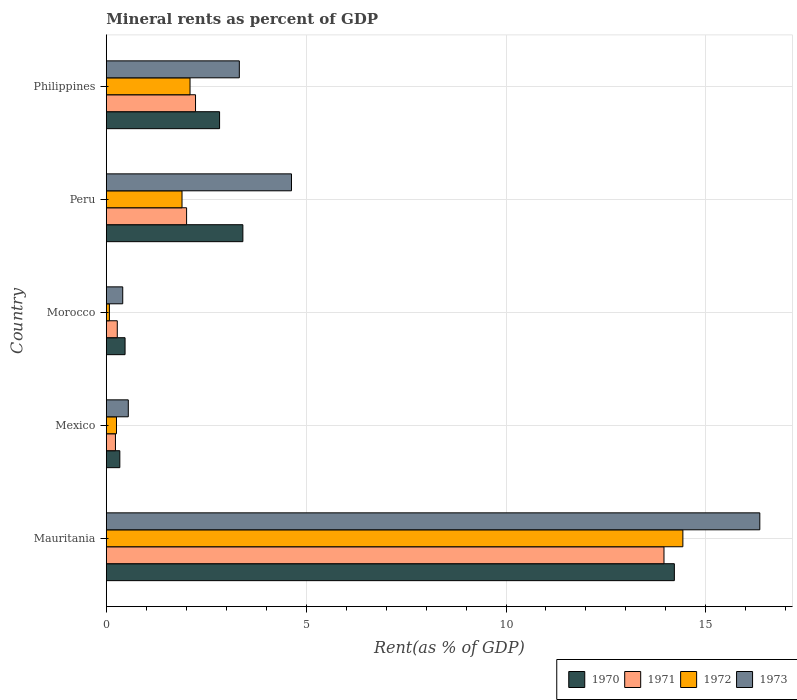How many groups of bars are there?
Ensure brevity in your answer.  5. How many bars are there on the 5th tick from the top?
Offer a terse response. 4. How many bars are there on the 4th tick from the bottom?
Your answer should be compact. 4. What is the label of the 4th group of bars from the top?
Give a very brief answer. Mexico. In how many cases, is the number of bars for a given country not equal to the number of legend labels?
Provide a succinct answer. 0. What is the mineral rent in 1970 in Morocco?
Offer a very short reply. 0.47. Across all countries, what is the maximum mineral rent in 1971?
Make the answer very short. 13.95. Across all countries, what is the minimum mineral rent in 1973?
Offer a terse response. 0.41. In which country was the mineral rent in 1973 maximum?
Ensure brevity in your answer.  Mauritania. What is the total mineral rent in 1971 in the graph?
Keep it short and to the point. 18.69. What is the difference between the mineral rent in 1971 in Mauritania and that in Philippines?
Your answer should be very brief. 11.72. What is the difference between the mineral rent in 1970 in Morocco and the mineral rent in 1973 in Mauritania?
Ensure brevity in your answer.  -15.88. What is the average mineral rent in 1970 per country?
Your response must be concise. 4.25. What is the difference between the mineral rent in 1970 and mineral rent in 1973 in Morocco?
Ensure brevity in your answer.  0.06. What is the ratio of the mineral rent in 1970 in Morocco to that in Philippines?
Your response must be concise. 0.17. What is the difference between the highest and the second highest mineral rent in 1971?
Your response must be concise. 11.72. What is the difference between the highest and the lowest mineral rent in 1973?
Provide a succinct answer. 15.94. Is the sum of the mineral rent in 1970 in Morocco and Peru greater than the maximum mineral rent in 1972 across all countries?
Ensure brevity in your answer.  No. Is it the case that in every country, the sum of the mineral rent in 1972 and mineral rent in 1971 is greater than the sum of mineral rent in 1973 and mineral rent in 1970?
Offer a terse response. No. What does the 3rd bar from the top in Morocco represents?
Your response must be concise. 1971. Is it the case that in every country, the sum of the mineral rent in 1972 and mineral rent in 1970 is greater than the mineral rent in 1973?
Offer a very short reply. Yes. Are all the bars in the graph horizontal?
Offer a terse response. Yes. How many countries are there in the graph?
Offer a very short reply. 5. Are the values on the major ticks of X-axis written in scientific E-notation?
Your answer should be compact. No. How many legend labels are there?
Your answer should be compact. 4. What is the title of the graph?
Your answer should be compact. Mineral rents as percent of GDP. What is the label or title of the X-axis?
Offer a very short reply. Rent(as % of GDP). What is the label or title of the Y-axis?
Your response must be concise. Country. What is the Rent(as % of GDP) in 1970 in Mauritania?
Offer a very short reply. 14.21. What is the Rent(as % of GDP) of 1971 in Mauritania?
Offer a terse response. 13.95. What is the Rent(as % of GDP) in 1972 in Mauritania?
Give a very brief answer. 14.43. What is the Rent(as % of GDP) of 1973 in Mauritania?
Give a very brief answer. 16.35. What is the Rent(as % of GDP) of 1970 in Mexico?
Make the answer very short. 0.34. What is the Rent(as % of GDP) in 1971 in Mexico?
Make the answer very short. 0.23. What is the Rent(as % of GDP) in 1972 in Mexico?
Provide a short and direct response. 0.25. What is the Rent(as % of GDP) in 1973 in Mexico?
Ensure brevity in your answer.  0.55. What is the Rent(as % of GDP) in 1970 in Morocco?
Make the answer very short. 0.47. What is the Rent(as % of GDP) in 1971 in Morocco?
Make the answer very short. 0.27. What is the Rent(as % of GDP) of 1972 in Morocco?
Provide a short and direct response. 0.08. What is the Rent(as % of GDP) of 1973 in Morocco?
Your answer should be very brief. 0.41. What is the Rent(as % of GDP) in 1970 in Peru?
Your response must be concise. 3.42. What is the Rent(as % of GDP) of 1971 in Peru?
Your response must be concise. 2.01. What is the Rent(as % of GDP) in 1972 in Peru?
Provide a succinct answer. 1.89. What is the Rent(as % of GDP) of 1973 in Peru?
Your answer should be very brief. 4.63. What is the Rent(as % of GDP) of 1970 in Philippines?
Offer a very short reply. 2.83. What is the Rent(as % of GDP) in 1971 in Philippines?
Make the answer very short. 2.23. What is the Rent(as % of GDP) in 1972 in Philippines?
Keep it short and to the point. 2.09. What is the Rent(as % of GDP) of 1973 in Philippines?
Ensure brevity in your answer.  3.33. Across all countries, what is the maximum Rent(as % of GDP) in 1970?
Ensure brevity in your answer.  14.21. Across all countries, what is the maximum Rent(as % of GDP) of 1971?
Provide a succinct answer. 13.95. Across all countries, what is the maximum Rent(as % of GDP) of 1972?
Your answer should be very brief. 14.43. Across all countries, what is the maximum Rent(as % of GDP) in 1973?
Your response must be concise. 16.35. Across all countries, what is the minimum Rent(as % of GDP) of 1970?
Your answer should be compact. 0.34. Across all countries, what is the minimum Rent(as % of GDP) in 1971?
Give a very brief answer. 0.23. Across all countries, what is the minimum Rent(as % of GDP) of 1972?
Ensure brevity in your answer.  0.08. Across all countries, what is the minimum Rent(as % of GDP) of 1973?
Your response must be concise. 0.41. What is the total Rent(as % of GDP) of 1970 in the graph?
Give a very brief answer. 21.27. What is the total Rent(as % of GDP) of 1971 in the graph?
Provide a short and direct response. 18.69. What is the total Rent(as % of GDP) of 1972 in the graph?
Your answer should be compact. 18.74. What is the total Rent(as % of GDP) in 1973 in the graph?
Keep it short and to the point. 25.27. What is the difference between the Rent(as % of GDP) in 1970 in Mauritania and that in Mexico?
Offer a terse response. 13.88. What is the difference between the Rent(as % of GDP) of 1971 in Mauritania and that in Mexico?
Offer a very short reply. 13.72. What is the difference between the Rent(as % of GDP) in 1972 in Mauritania and that in Mexico?
Offer a terse response. 14.17. What is the difference between the Rent(as % of GDP) of 1973 in Mauritania and that in Mexico?
Provide a short and direct response. 15.8. What is the difference between the Rent(as % of GDP) in 1970 in Mauritania and that in Morocco?
Keep it short and to the point. 13.74. What is the difference between the Rent(as % of GDP) in 1971 in Mauritania and that in Morocco?
Provide a succinct answer. 13.68. What is the difference between the Rent(as % of GDP) of 1972 in Mauritania and that in Morocco?
Keep it short and to the point. 14.35. What is the difference between the Rent(as % of GDP) in 1973 in Mauritania and that in Morocco?
Offer a very short reply. 15.94. What is the difference between the Rent(as % of GDP) in 1970 in Mauritania and that in Peru?
Your response must be concise. 10.8. What is the difference between the Rent(as % of GDP) in 1971 in Mauritania and that in Peru?
Offer a terse response. 11.94. What is the difference between the Rent(as % of GDP) of 1972 in Mauritania and that in Peru?
Keep it short and to the point. 12.53. What is the difference between the Rent(as % of GDP) of 1973 in Mauritania and that in Peru?
Make the answer very short. 11.72. What is the difference between the Rent(as % of GDP) in 1970 in Mauritania and that in Philippines?
Make the answer very short. 11.38. What is the difference between the Rent(as % of GDP) of 1971 in Mauritania and that in Philippines?
Ensure brevity in your answer.  11.72. What is the difference between the Rent(as % of GDP) of 1972 in Mauritania and that in Philippines?
Ensure brevity in your answer.  12.33. What is the difference between the Rent(as % of GDP) in 1973 in Mauritania and that in Philippines?
Your answer should be compact. 13.02. What is the difference between the Rent(as % of GDP) of 1970 in Mexico and that in Morocco?
Your answer should be compact. -0.13. What is the difference between the Rent(as % of GDP) in 1971 in Mexico and that in Morocco?
Offer a very short reply. -0.05. What is the difference between the Rent(as % of GDP) in 1972 in Mexico and that in Morocco?
Offer a terse response. 0.18. What is the difference between the Rent(as % of GDP) of 1973 in Mexico and that in Morocco?
Ensure brevity in your answer.  0.14. What is the difference between the Rent(as % of GDP) of 1970 in Mexico and that in Peru?
Offer a very short reply. -3.08. What is the difference between the Rent(as % of GDP) in 1971 in Mexico and that in Peru?
Ensure brevity in your answer.  -1.78. What is the difference between the Rent(as % of GDP) in 1972 in Mexico and that in Peru?
Your answer should be very brief. -1.64. What is the difference between the Rent(as % of GDP) of 1973 in Mexico and that in Peru?
Your response must be concise. -4.08. What is the difference between the Rent(as % of GDP) of 1970 in Mexico and that in Philippines?
Offer a terse response. -2.5. What is the difference between the Rent(as % of GDP) of 1971 in Mexico and that in Philippines?
Your response must be concise. -2. What is the difference between the Rent(as % of GDP) of 1972 in Mexico and that in Philippines?
Provide a succinct answer. -1.84. What is the difference between the Rent(as % of GDP) of 1973 in Mexico and that in Philippines?
Give a very brief answer. -2.78. What is the difference between the Rent(as % of GDP) in 1970 in Morocco and that in Peru?
Provide a short and direct response. -2.95. What is the difference between the Rent(as % of GDP) in 1971 in Morocco and that in Peru?
Provide a succinct answer. -1.73. What is the difference between the Rent(as % of GDP) of 1972 in Morocco and that in Peru?
Make the answer very short. -1.82. What is the difference between the Rent(as % of GDP) of 1973 in Morocco and that in Peru?
Offer a terse response. -4.22. What is the difference between the Rent(as % of GDP) in 1970 in Morocco and that in Philippines?
Your response must be concise. -2.36. What is the difference between the Rent(as % of GDP) in 1971 in Morocco and that in Philippines?
Make the answer very short. -1.96. What is the difference between the Rent(as % of GDP) of 1972 in Morocco and that in Philippines?
Offer a very short reply. -2.02. What is the difference between the Rent(as % of GDP) in 1973 in Morocco and that in Philippines?
Make the answer very short. -2.92. What is the difference between the Rent(as % of GDP) in 1970 in Peru and that in Philippines?
Make the answer very short. 0.58. What is the difference between the Rent(as % of GDP) in 1971 in Peru and that in Philippines?
Give a very brief answer. -0.22. What is the difference between the Rent(as % of GDP) of 1972 in Peru and that in Philippines?
Provide a succinct answer. -0.2. What is the difference between the Rent(as % of GDP) of 1973 in Peru and that in Philippines?
Give a very brief answer. 1.31. What is the difference between the Rent(as % of GDP) in 1970 in Mauritania and the Rent(as % of GDP) in 1971 in Mexico?
Make the answer very short. 13.98. What is the difference between the Rent(as % of GDP) of 1970 in Mauritania and the Rent(as % of GDP) of 1972 in Mexico?
Make the answer very short. 13.96. What is the difference between the Rent(as % of GDP) in 1970 in Mauritania and the Rent(as % of GDP) in 1973 in Mexico?
Your answer should be very brief. 13.66. What is the difference between the Rent(as % of GDP) of 1971 in Mauritania and the Rent(as % of GDP) of 1972 in Mexico?
Keep it short and to the point. 13.7. What is the difference between the Rent(as % of GDP) in 1971 in Mauritania and the Rent(as % of GDP) in 1973 in Mexico?
Your answer should be very brief. 13.4. What is the difference between the Rent(as % of GDP) of 1972 in Mauritania and the Rent(as % of GDP) of 1973 in Mexico?
Make the answer very short. 13.88. What is the difference between the Rent(as % of GDP) in 1970 in Mauritania and the Rent(as % of GDP) in 1971 in Morocco?
Provide a succinct answer. 13.94. What is the difference between the Rent(as % of GDP) of 1970 in Mauritania and the Rent(as % of GDP) of 1972 in Morocco?
Ensure brevity in your answer.  14.14. What is the difference between the Rent(as % of GDP) of 1970 in Mauritania and the Rent(as % of GDP) of 1973 in Morocco?
Make the answer very short. 13.8. What is the difference between the Rent(as % of GDP) of 1971 in Mauritania and the Rent(as % of GDP) of 1972 in Morocco?
Make the answer very short. 13.88. What is the difference between the Rent(as % of GDP) in 1971 in Mauritania and the Rent(as % of GDP) in 1973 in Morocco?
Give a very brief answer. 13.54. What is the difference between the Rent(as % of GDP) in 1972 in Mauritania and the Rent(as % of GDP) in 1973 in Morocco?
Offer a terse response. 14.02. What is the difference between the Rent(as % of GDP) in 1970 in Mauritania and the Rent(as % of GDP) in 1971 in Peru?
Ensure brevity in your answer.  12.2. What is the difference between the Rent(as % of GDP) in 1970 in Mauritania and the Rent(as % of GDP) in 1972 in Peru?
Keep it short and to the point. 12.32. What is the difference between the Rent(as % of GDP) in 1970 in Mauritania and the Rent(as % of GDP) in 1973 in Peru?
Provide a succinct answer. 9.58. What is the difference between the Rent(as % of GDP) in 1971 in Mauritania and the Rent(as % of GDP) in 1972 in Peru?
Offer a very short reply. 12.06. What is the difference between the Rent(as % of GDP) in 1971 in Mauritania and the Rent(as % of GDP) in 1973 in Peru?
Give a very brief answer. 9.32. What is the difference between the Rent(as % of GDP) in 1972 in Mauritania and the Rent(as % of GDP) in 1973 in Peru?
Provide a succinct answer. 9.79. What is the difference between the Rent(as % of GDP) of 1970 in Mauritania and the Rent(as % of GDP) of 1971 in Philippines?
Provide a short and direct response. 11.98. What is the difference between the Rent(as % of GDP) in 1970 in Mauritania and the Rent(as % of GDP) in 1972 in Philippines?
Provide a short and direct response. 12.12. What is the difference between the Rent(as % of GDP) in 1970 in Mauritania and the Rent(as % of GDP) in 1973 in Philippines?
Ensure brevity in your answer.  10.89. What is the difference between the Rent(as % of GDP) in 1971 in Mauritania and the Rent(as % of GDP) in 1972 in Philippines?
Keep it short and to the point. 11.86. What is the difference between the Rent(as % of GDP) of 1971 in Mauritania and the Rent(as % of GDP) of 1973 in Philippines?
Provide a short and direct response. 10.63. What is the difference between the Rent(as % of GDP) of 1972 in Mauritania and the Rent(as % of GDP) of 1973 in Philippines?
Offer a very short reply. 11.1. What is the difference between the Rent(as % of GDP) of 1970 in Mexico and the Rent(as % of GDP) of 1971 in Morocco?
Provide a succinct answer. 0.06. What is the difference between the Rent(as % of GDP) of 1970 in Mexico and the Rent(as % of GDP) of 1972 in Morocco?
Ensure brevity in your answer.  0.26. What is the difference between the Rent(as % of GDP) in 1970 in Mexico and the Rent(as % of GDP) in 1973 in Morocco?
Your response must be concise. -0.07. What is the difference between the Rent(as % of GDP) in 1971 in Mexico and the Rent(as % of GDP) in 1972 in Morocco?
Offer a terse response. 0.15. What is the difference between the Rent(as % of GDP) of 1971 in Mexico and the Rent(as % of GDP) of 1973 in Morocco?
Keep it short and to the point. -0.18. What is the difference between the Rent(as % of GDP) of 1972 in Mexico and the Rent(as % of GDP) of 1973 in Morocco?
Provide a succinct answer. -0.16. What is the difference between the Rent(as % of GDP) in 1970 in Mexico and the Rent(as % of GDP) in 1971 in Peru?
Offer a very short reply. -1.67. What is the difference between the Rent(as % of GDP) of 1970 in Mexico and the Rent(as % of GDP) of 1972 in Peru?
Offer a terse response. -1.56. What is the difference between the Rent(as % of GDP) of 1970 in Mexico and the Rent(as % of GDP) of 1973 in Peru?
Offer a very short reply. -4.29. What is the difference between the Rent(as % of GDP) of 1971 in Mexico and the Rent(as % of GDP) of 1972 in Peru?
Your answer should be very brief. -1.67. What is the difference between the Rent(as % of GDP) in 1971 in Mexico and the Rent(as % of GDP) in 1973 in Peru?
Offer a very short reply. -4.4. What is the difference between the Rent(as % of GDP) of 1972 in Mexico and the Rent(as % of GDP) of 1973 in Peru?
Ensure brevity in your answer.  -4.38. What is the difference between the Rent(as % of GDP) of 1970 in Mexico and the Rent(as % of GDP) of 1971 in Philippines?
Offer a very short reply. -1.89. What is the difference between the Rent(as % of GDP) of 1970 in Mexico and the Rent(as % of GDP) of 1972 in Philippines?
Keep it short and to the point. -1.76. What is the difference between the Rent(as % of GDP) of 1970 in Mexico and the Rent(as % of GDP) of 1973 in Philippines?
Offer a terse response. -2.99. What is the difference between the Rent(as % of GDP) in 1971 in Mexico and the Rent(as % of GDP) in 1972 in Philippines?
Offer a very short reply. -1.87. What is the difference between the Rent(as % of GDP) of 1971 in Mexico and the Rent(as % of GDP) of 1973 in Philippines?
Your answer should be compact. -3.1. What is the difference between the Rent(as % of GDP) in 1972 in Mexico and the Rent(as % of GDP) in 1973 in Philippines?
Offer a very short reply. -3.07. What is the difference between the Rent(as % of GDP) of 1970 in Morocco and the Rent(as % of GDP) of 1971 in Peru?
Ensure brevity in your answer.  -1.54. What is the difference between the Rent(as % of GDP) in 1970 in Morocco and the Rent(as % of GDP) in 1972 in Peru?
Your response must be concise. -1.43. What is the difference between the Rent(as % of GDP) of 1970 in Morocco and the Rent(as % of GDP) of 1973 in Peru?
Provide a short and direct response. -4.16. What is the difference between the Rent(as % of GDP) of 1971 in Morocco and the Rent(as % of GDP) of 1972 in Peru?
Provide a succinct answer. -1.62. What is the difference between the Rent(as % of GDP) of 1971 in Morocco and the Rent(as % of GDP) of 1973 in Peru?
Your answer should be compact. -4.36. What is the difference between the Rent(as % of GDP) in 1972 in Morocco and the Rent(as % of GDP) in 1973 in Peru?
Make the answer very short. -4.56. What is the difference between the Rent(as % of GDP) of 1970 in Morocco and the Rent(as % of GDP) of 1971 in Philippines?
Provide a short and direct response. -1.76. What is the difference between the Rent(as % of GDP) of 1970 in Morocco and the Rent(as % of GDP) of 1972 in Philippines?
Provide a succinct answer. -1.63. What is the difference between the Rent(as % of GDP) in 1970 in Morocco and the Rent(as % of GDP) in 1973 in Philippines?
Keep it short and to the point. -2.86. What is the difference between the Rent(as % of GDP) in 1971 in Morocco and the Rent(as % of GDP) in 1972 in Philippines?
Provide a succinct answer. -1.82. What is the difference between the Rent(as % of GDP) in 1971 in Morocco and the Rent(as % of GDP) in 1973 in Philippines?
Provide a short and direct response. -3.05. What is the difference between the Rent(as % of GDP) in 1972 in Morocco and the Rent(as % of GDP) in 1973 in Philippines?
Your response must be concise. -3.25. What is the difference between the Rent(as % of GDP) of 1970 in Peru and the Rent(as % of GDP) of 1971 in Philippines?
Your answer should be very brief. 1.18. What is the difference between the Rent(as % of GDP) in 1970 in Peru and the Rent(as % of GDP) in 1972 in Philippines?
Offer a very short reply. 1.32. What is the difference between the Rent(as % of GDP) of 1970 in Peru and the Rent(as % of GDP) of 1973 in Philippines?
Ensure brevity in your answer.  0.09. What is the difference between the Rent(as % of GDP) in 1971 in Peru and the Rent(as % of GDP) in 1972 in Philippines?
Ensure brevity in your answer.  -0.09. What is the difference between the Rent(as % of GDP) of 1971 in Peru and the Rent(as % of GDP) of 1973 in Philippines?
Provide a short and direct response. -1.32. What is the difference between the Rent(as % of GDP) in 1972 in Peru and the Rent(as % of GDP) in 1973 in Philippines?
Give a very brief answer. -1.43. What is the average Rent(as % of GDP) of 1970 per country?
Keep it short and to the point. 4.25. What is the average Rent(as % of GDP) of 1971 per country?
Give a very brief answer. 3.74. What is the average Rent(as % of GDP) in 1972 per country?
Give a very brief answer. 3.75. What is the average Rent(as % of GDP) of 1973 per country?
Offer a terse response. 5.05. What is the difference between the Rent(as % of GDP) in 1970 and Rent(as % of GDP) in 1971 in Mauritania?
Offer a terse response. 0.26. What is the difference between the Rent(as % of GDP) in 1970 and Rent(as % of GDP) in 1972 in Mauritania?
Keep it short and to the point. -0.21. What is the difference between the Rent(as % of GDP) of 1970 and Rent(as % of GDP) of 1973 in Mauritania?
Your answer should be compact. -2.14. What is the difference between the Rent(as % of GDP) in 1971 and Rent(as % of GDP) in 1972 in Mauritania?
Your answer should be compact. -0.47. What is the difference between the Rent(as % of GDP) of 1971 and Rent(as % of GDP) of 1973 in Mauritania?
Ensure brevity in your answer.  -2.4. What is the difference between the Rent(as % of GDP) of 1972 and Rent(as % of GDP) of 1973 in Mauritania?
Give a very brief answer. -1.93. What is the difference between the Rent(as % of GDP) of 1970 and Rent(as % of GDP) of 1971 in Mexico?
Provide a succinct answer. 0.11. What is the difference between the Rent(as % of GDP) in 1970 and Rent(as % of GDP) in 1972 in Mexico?
Your response must be concise. 0.08. What is the difference between the Rent(as % of GDP) of 1970 and Rent(as % of GDP) of 1973 in Mexico?
Offer a very short reply. -0.21. What is the difference between the Rent(as % of GDP) of 1971 and Rent(as % of GDP) of 1972 in Mexico?
Offer a terse response. -0.03. What is the difference between the Rent(as % of GDP) of 1971 and Rent(as % of GDP) of 1973 in Mexico?
Offer a very short reply. -0.32. What is the difference between the Rent(as % of GDP) in 1972 and Rent(as % of GDP) in 1973 in Mexico?
Your answer should be very brief. -0.3. What is the difference between the Rent(as % of GDP) in 1970 and Rent(as % of GDP) in 1971 in Morocco?
Offer a terse response. 0.19. What is the difference between the Rent(as % of GDP) in 1970 and Rent(as % of GDP) in 1972 in Morocco?
Give a very brief answer. 0.39. What is the difference between the Rent(as % of GDP) in 1970 and Rent(as % of GDP) in 1973 in Morocco?
Make the answer very short. 0.06. What is the difference between the Rent(as % of GDP) in 1971 and Rent(as % of GDP) in 1972 in Morocco?
Ensure brevity in your answer.  0.2. What is the difference between the Rent(as % of GDP) of 1971 and Rent(as % of GDP) of 1973 in Morocco?
Your answer should be very brief. -0.14. What is the difference between the Rent(as % of GDP) of 1972 and Rent(as % of GDP) of 1973 in Morocco?
Provide a short and direct response. -0.33. What is the difference between the Rent(as % of GDP) of 1970 and Rent(as % of GDP) of 1971 in Peru?
Make the answer very short. 1.41. What is the difference between the Rent(as % of GDP) of 1970 and Rent(as % of GDP) of 1972 in Peru?
Provide a short and direct response. 1.52. What is the difference between the Rent(as % of GDP) in 1970 and Rent(as % of GDP) in 1973 in Peru?
Make the answer very short. -1.22. What is the difference between the Rent(as % of GDP) in 1971 and Rent(as % of GDP) in 1972 in Peru?
Keep it short and to the point. 0.11. What is the difference between the Rent(as % of GDP) in 1971 and Rent(as % of GDP) in 1973 in Peru?
Provide a short and direct response. -2.62. What is the difference between the Rent(as % of GDP) in 1972 and Rent(as % of GDP) in 1973 in Peru?
Offer a terse response. -2.74. What is the difference between the Rent(as % of GDP) of 1970 and Rent(as % of GDP) of 1971 in Philippines?
Provide a short and direct response. 0.6. What is the difference between the Rent(as % of GDP) in 1970 and Rent(as % of GDP) in 1972 in Philippines?
Your response must be concise. 0.74. What is the difference between the Rent(as % of GDP) in 1970 and Rent(as % of GDP) in 1973 in Philippines?
Provide a short and direct response. -0.49. What is the difference between the Rent(as % of GDP) in 1971 and Rent(as % of GDP) in 1972 in Philippines?
Your answer should be very brief. 0.14. What is the difference between the Rent(as % of GDP) in 1971 and Rent(as % of GDP) in 1973 in Philippines?
Ensure brevity in your answer.  -1.1. What is the difference between the Rent(as % of GDP) of 1972 and Rent(as % of GDP) of 1973 in Philippines?
Offer a terse response. -1.23. What is the ratio of the Rent(as % of GDP) in 1970 in Mauritania to that in Mexico?
Provide a succinct answer. 42.1. What is the ratio of the Rent(as % of GDP) in 1971 in Mauritania to that in Mexico?
Your response must be concise. 61.1. What is the ratio of the Rent(as % of GDP) of 1972 in Mauritania to that in Mexico?
Make the answer very short. 56.78. What is the ratio of the Rent(as % of GDP) in 1973 in Mauritania to that in Mexico?
Keep it short and to the point. 29.75. What is the ratio of the Rent(as % of GDP) of 1970 in Mauritania to that in Morocco?
Offer a very short reply. 30.32. What is the ratio of the Rent(as % of GDP) in 1971 in Mauritania to that in Morocco?
Provide a succinct answer. 50.9. What is the ratio of the Rent(as % of GDP) of 1972 in Mauritania to that in Morocco?
Your response must be concise. 187.82. What is the ratio of the Rent(as % of GDP) in 1973 in Mauritania to that in Morocco?
Offer a very short reply. 39.85. What is the ratio of the Rent(as % of GDP) in 1970 in Mauritania to that in Peru?
Make the answer very short. 4.16. What is the ratio of the Rent(as % of GDP) in 1971 in Mauritania to that in Peru?
Offer a very short reply. 6.95. What is the ratio of the Rent(as % of GDP) of 1972 in Mauritania to that in Peru?
Offer a terse response. 7.62. What is the ratio of the Rent(as % of GDP) in 1973 in Mauritania to that in Peru?
Your answer should be very brief. 3.53. What is the ratio of the Rent(as % of GDP) in 1970 in Mauritania to that in Philippines?
Your answer should be very brief. 5.02. What is the ratio of the Rent(as % of GDP) in 1971 in Mauritania to that in Philippines?
Provide a short and direct response. 6.25. What is the ratio of the Rent(as % of GDP) in 1972 in Mauritania to that in Philippines?
Your response must be concise. 6.89. What is the ratio of the Rent(as % of GDP) in 1973 in Mauritania to that in Philippines?
Ensure brevity in your answer.  4.91. What is the ratio of the Rent(as % of GDP) of 1970 in Mexico to that in Morocco?
Your answer should be very brief. 0.72. What is the ratio of the Rent(as % of GDP) of 1971 in Mexico to that in Morocco?
Provide a succinct answer. 0.83. What is the ratio of the Rent(as % of GDP) in 1972 in Mexico to that in Morocco?
Offer a terse response. 3.31. What is the ratio of the Rent(as % of GDP) of 1973 in Mexico to that in Morocco?
Your response must be concise. 1.34. What is the ratio of the Rent(as % of GDP) in 1970 in Mexico to that in Peru?
Provide a succinct answer. 0.1. What is the ratio of the Rent(as % of GDP) of 1971 in Mexico to that in Peru?
Give a very brief answer. 0.11. What is the ratio of the Rent(as % of GDP) of 1972 in Mexico to that in Peru?
Your response must be concise. 0.13. What is the ratio of the Rent(as % of GDP) of 1973 in Mexico to that in Peru?
Your answer should be compact. 0.12. What is the ratio of the Rent(as % of GDP) in 1970 in Mexico to that in Philippines?
Offer a very short reply. 0.12. What is the ratio of the Rent(as % of GDP) of 1971 in Mexico to that in Philippines?
Your response must be concise. 0.1. What is the ratio of the Rent(as % of GDP) of 1972 in Mexico to that in Philippines?
Make the answer very short. 0.12. What is the ratio of the Rent(as % of GDP) in 1973 in Mexico to that in Philippines?
Make the answer very short. 0.17. What is the ratio of the Rent(as % of GDP) in 1970 in Morocco to that in Peru?
Keep it short and to the point. 0.14. What is the ratio of the Rent(as % of GDP) of 1971 in Morocco to that in Peru?
Provide a succinct answer. 0.14. What is the ratio of the Rent(as % of GDP) in 1972 in Morocco to that in Peru?
Offer a very short reply. 0.04. What is the ratio of the Rent(as % of GDP) of 1973 in Morocco to that in Peru?
Ensure brevity in your answer.  0.09. What is the ratio of the Rent(as % of GDP) in 1970 in Morocco to that in Philippines?
Offer a very short reply. 0.17. What is the ratio of the Rent(as % of GDP) in 1971 in Morocco to that in Philippines?
Provide a succinct answer. 0.12. What is the ratio of the Rent(as % of GDP) in 1972 in Morocco to that in Philippines?
Provide a succinct answer. 0.04. What is the ratio of the Rent(as % of GDP) in 1973 in Morocco to that in Philippines?
Your answer should be compact. 0.12. What is the ratio of the Rent(as % of GDP) in 1970 in Peru to that in Philippines?
Keep it short and to the point. 1.21. What is the ratio of the Rent(as % of GDP) in 1971 in Peru to that in Philippines?
Keep it short and to the point. 0.9. What is the ratio of the Rent(as % of GDP) in 1972 in Peru to that in Philippines?
Give a very brief answer. 0.9. What is the ratio of the Rent(as % of GDP) in 1973 in Peru to that in Philippines?
Provide a succinct answer. 1.39. What is the difference between the highest and the second highest Rent(as % of GDP) of 1970?
Offer a terse response. 10.8. What is the difference between the highest and the second highest Rent(as % of GDP) of 1971?
Keep it short and to the point. 11.72. What is the difference between the highest and the second highest Rent(as % of GDP) of 1972?
Provide a succinct answer. 12.33. What is the difference between the highest and the second highest Rent(as % of GDP) of 1973?
Your response must be concise. 11.72. What is the difference between the highest and the lowest Rent(as % of GDP) in 1970?
Ensure brevity in your answer.  13.88. What is the difference between the highest and the lowest Rent(as % of GDP) of 1971?
Ensure brevity in your answer.  13.72. What is the difference between the highest and the lowest Rent(as % of GDP) in 1972?
Your response must be concise. 14.35. What is the difference between the highest and the lowest Rent(as % of GDP) of 1973?
Provide a short and direct response. 15.94. 